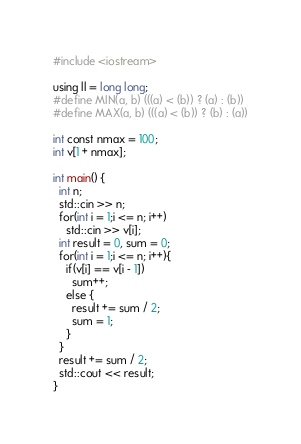Convert code to text. <code><loc_0><loc_0><loc_500><loc_500><_C++_>#include <iostream>

using ll = long long;
#define MIN(a, b) (((a) < (b)) ? (a) : (b))
#define MAX(a, b) (((a) < (b)) ? (b) : (a))

int const nmax = 100;
int v[1 + nmax];

int main() {
  int n;
  std::cin >> n;
  for(int i = 1;i <= n; i++)
    std::cin >> v[i];
  int result = 0, sum = 0;
  for(int i = 1;i <= n; i++){
    if(v[i] == v[i - 1])
      sum++;
    else {
      result += sum / 2;
      sum = 1;
    }
  }
  result += sum / 2;
  std::cout << result;
}
</code> 